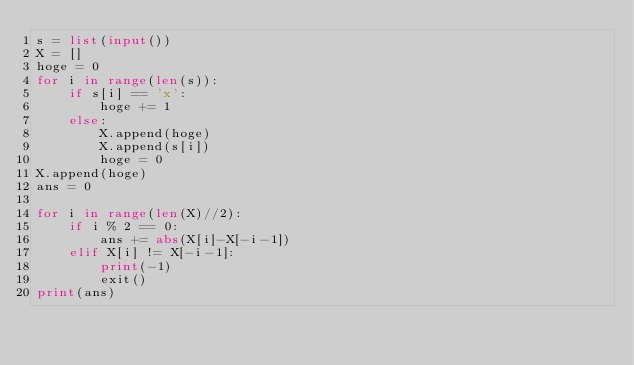Convert code to text. <code><loc_0><loc_0><loc_500><loc_500><_Python_>s = list(input())
X = []
hoge = 0
for i in range(len(s)):
    if s[i] == 'x':
        hoge += 1
    else:
        X.append(hoge)
        X.append(s[i])
        hoge = 0
X.append(hoge)
ans = 0

for i in range(len(X)//2):
    if i % 2 == 0:
        ans += abs(X[i]-X[-i-1])
    elif X[i] != X[-i-1]:
        print(-1)
        exit()
print(ans)</code> 